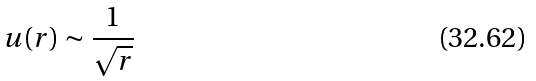Convert formula to latex. <formula><loc_0><loc_0><loc_500><loc_500>u ( r ) \sim \frac { 1 } { \sqrt { r } }</formula> 